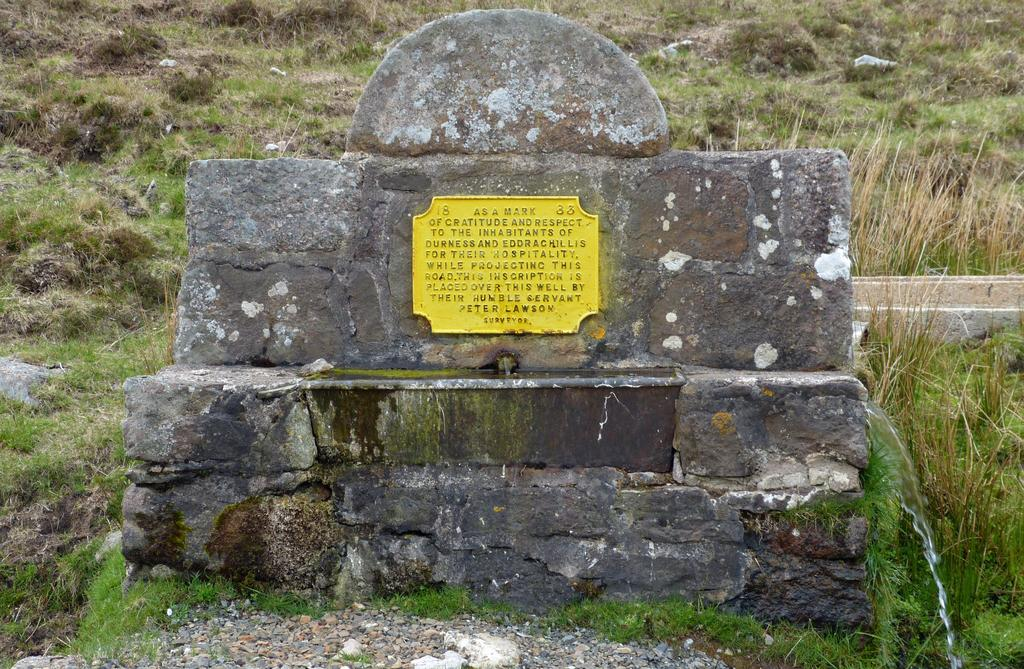What is the main object in the center of the image? There is a stone in the center of the image. What is placed on top of the stone? There is a board on the stone. What can be read or seen on the board? There is text engraved on the board. What type of natural environment is visible in the background of the image? There is grass and plants in the background of the image. Where is the stove located in the image? There is no stove present in the image. What type of coil can be seen wrapped around the plants in the image? There is no coil visible in the image, and the plants are not wrapped around anything. 